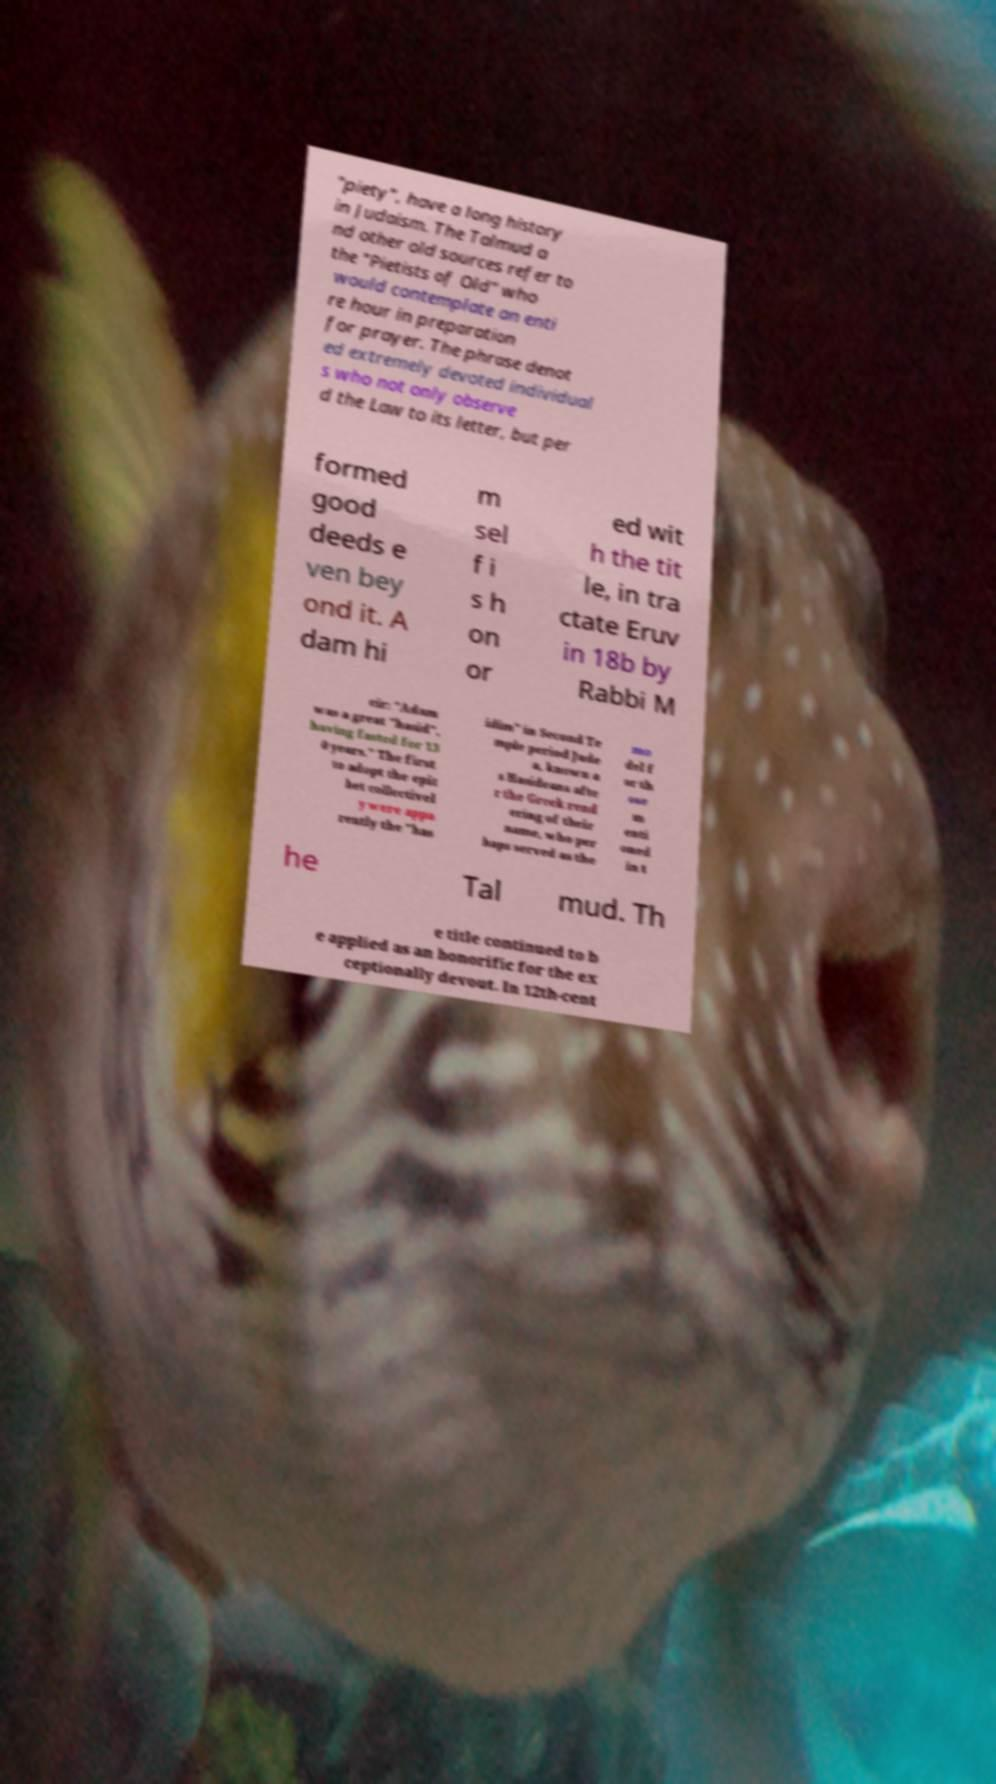Can you accurately transcribe the text from the provided image for me? "piety", have a long history in Judaism. The Talmud a nd other old sources refer to the "Pietists of Old" who would contemplate an enti re hour in preparation for prayer. The phrase denot ed extremely devoted individual s who not only observe d the Law to its letter, but per formed good deeds e ven bey ond it. A dam hi m sel f i s h on or ed wit h the tit le, in tra ctate Eruv in 18b by Rabbi M eir: "Adam was a great "hasid", having fasted for 13 0 years." The first to adopt the epit het collectivel y were appa rently the "has idim" in Second Te mple period Jude a, known a s Hasideans afte r the Greek rend ering of their name, who per haps served as the mo del f or th ose m enti oned in t he Tal mud. Th e title continued to b e applied as an honorific for the ex ceptionally devout. In 12th-cent 